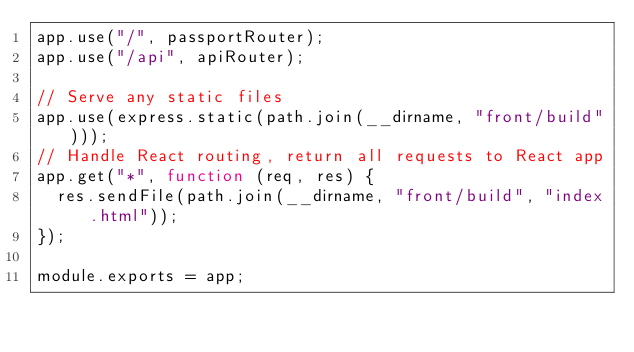<code> <loc_0><loc_0><loc_500><loc_500><_JavaScript_>app.use("/", passportRouter);
app.use("/api", apiRouter);

// Serve any static files
app.use(express.static(path.join(__dirname, "front/build")));
// Handle React routing, return all requests to React app
app.get("*", function (req, res) {
  res.sendFile(path.join(__dirname, "front/build", "index.html"));
});

module.exports = app;
</code> 